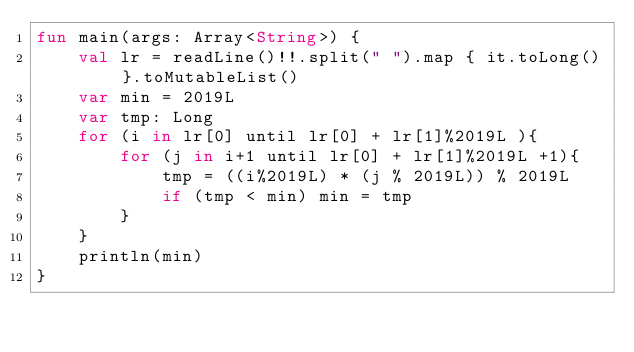<code> <loc_0><loc_0><loc_500><loc_500><_Kotlin_>fun main(args: Array<String>) {
    val lr = readLine()!!.split(" ").map { it.toLong() }.toMutableList()
    var min = 2019L
    var tmp: Long
    for (i in lr[0] until lr[0] + lr[1]%2019L ){
        for (j in i+1 until lr[0] + lr[1]%2019L +1){
            tmp = ((i%2019L) * (j % 2019L)) % 2019L
            if (tmp < min) min = tmp
        }
    }
    println(min)
}
</code> 